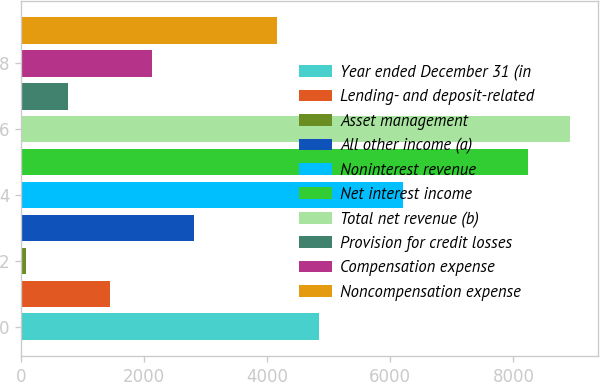Convert chart to OTSL. <chart><loc_0><loc_0><loc_500><loc_500><bar_chart><fcel>Year ended December 31 (in<fcel>Lending- and deposit-related<fcel>Asset management<fcel>All other income (a)<fcel>Noninterest revenue<fcel>Net interest income<fcel>Total net revenue (b)<fcel>Provision for credit losses<fcel>Compensation expense<fcel>Noncompensation expense<nl><fcel>4845.9<fcel>1447.4<fcel>88<fcel>2806.8<fcel>6205.3<fcel>8244.4<fcel>8924.1<fcel>767.7<fcel>2127.1<fcel>4166.2<nl></chart> 